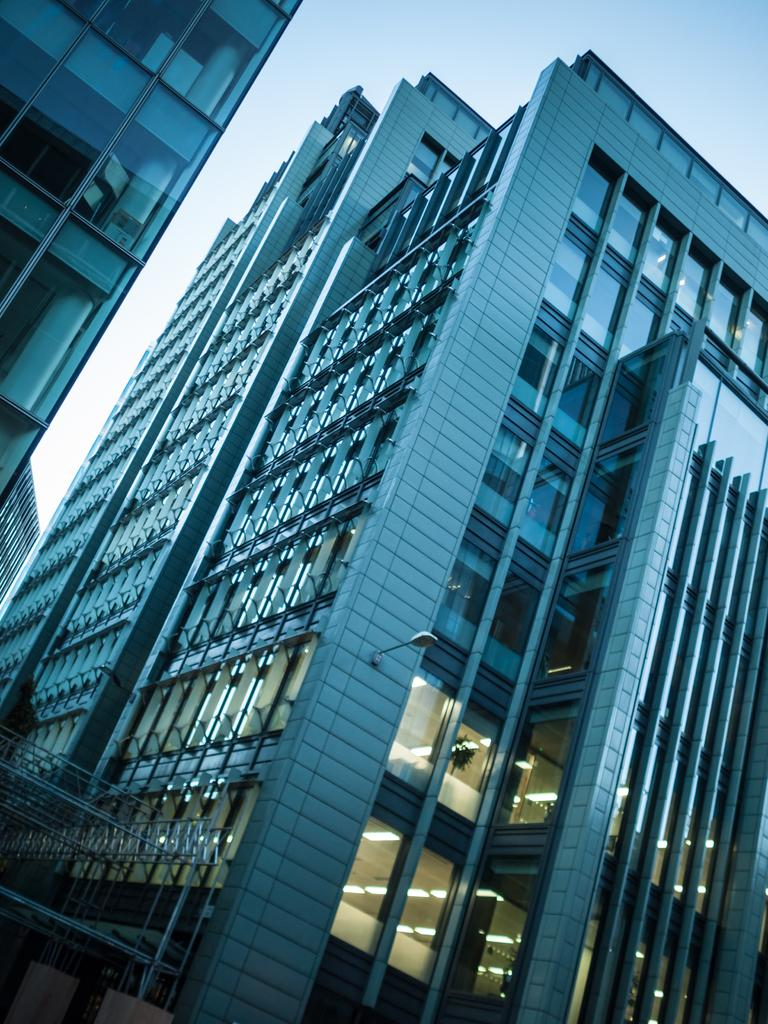What type of buildings are shown in the image? The buildings in the image have glass doors. Are there any visible sources of light in the image? Yes, lights are visible in the image. What material is used for the rods in the image? Iron rods are present in the image. What can be seen in the background of the image? The sky is visible in the background of the image. What type of alarm is set off by the mist in the image? There is no mist present in the image, so no alarm can be set off by it. 